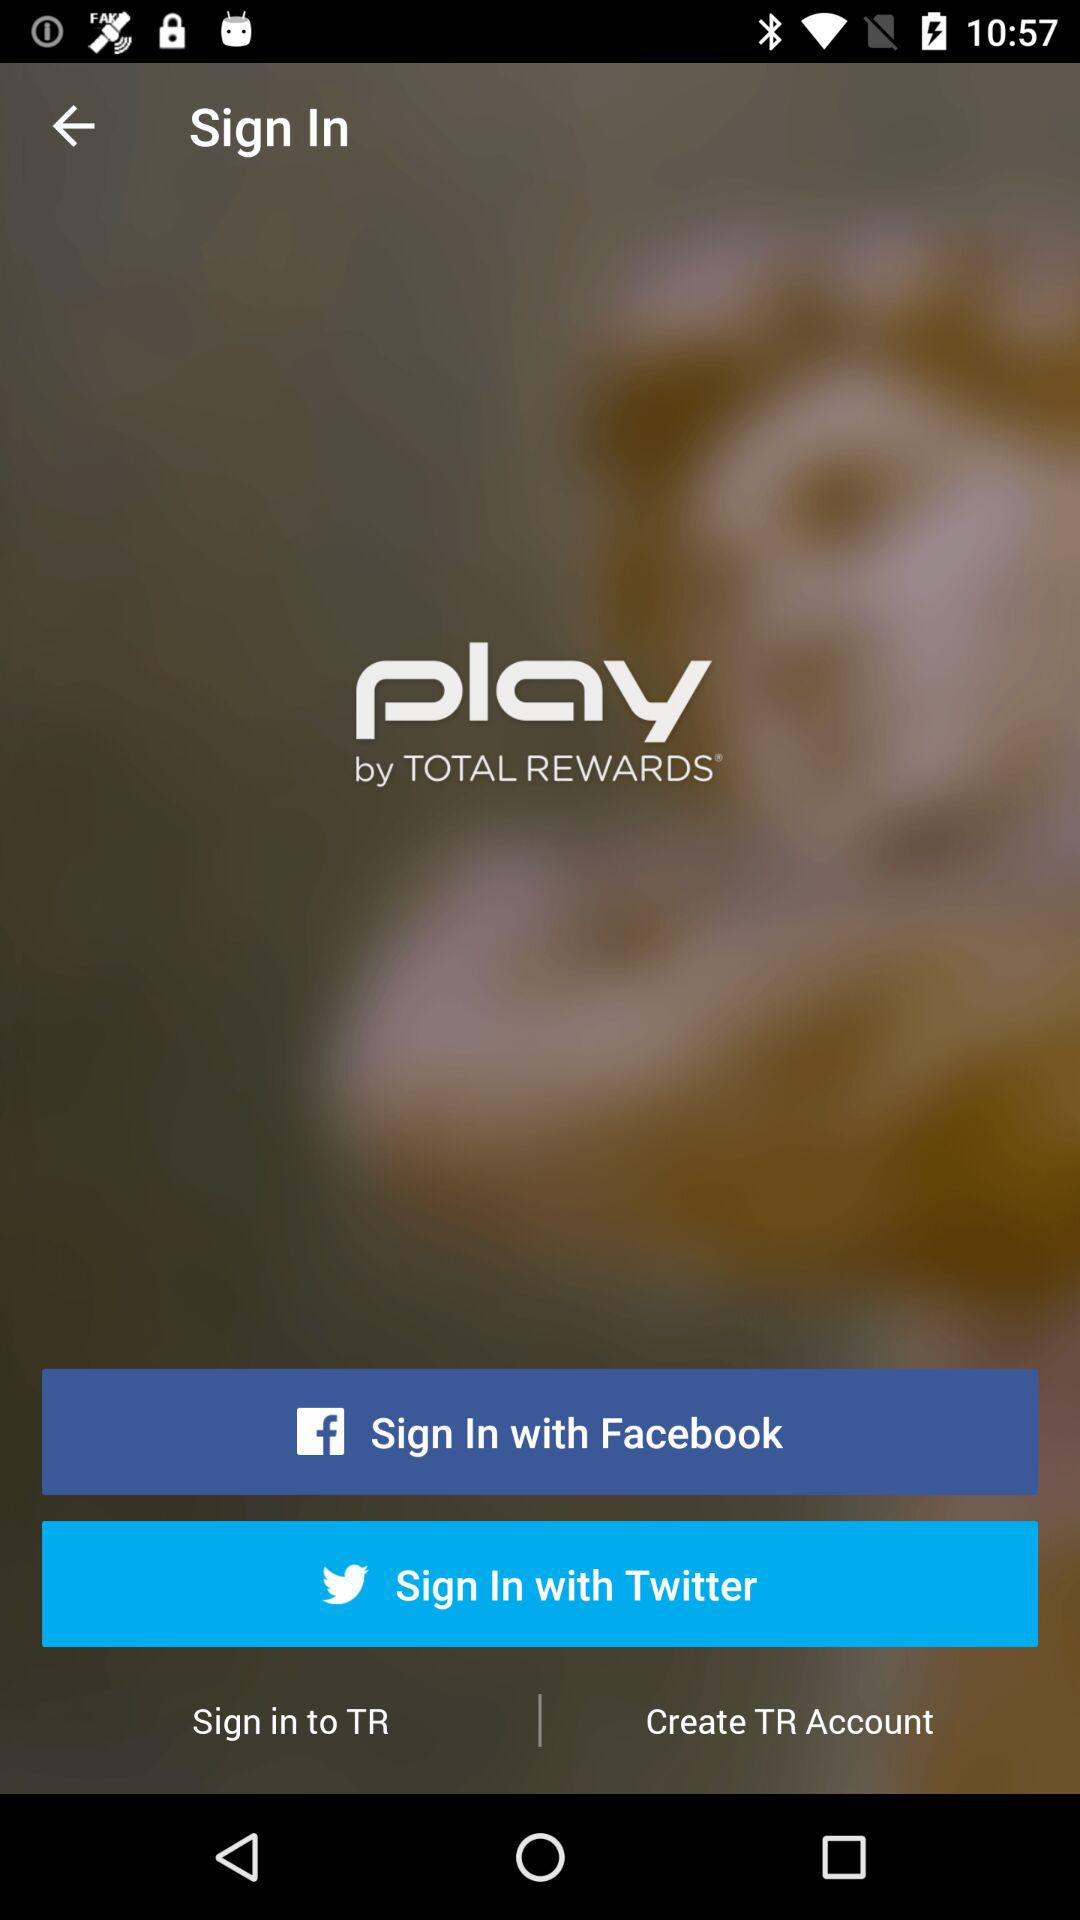What are the options to sign in? The options are "Facebook" and "Twitter". 